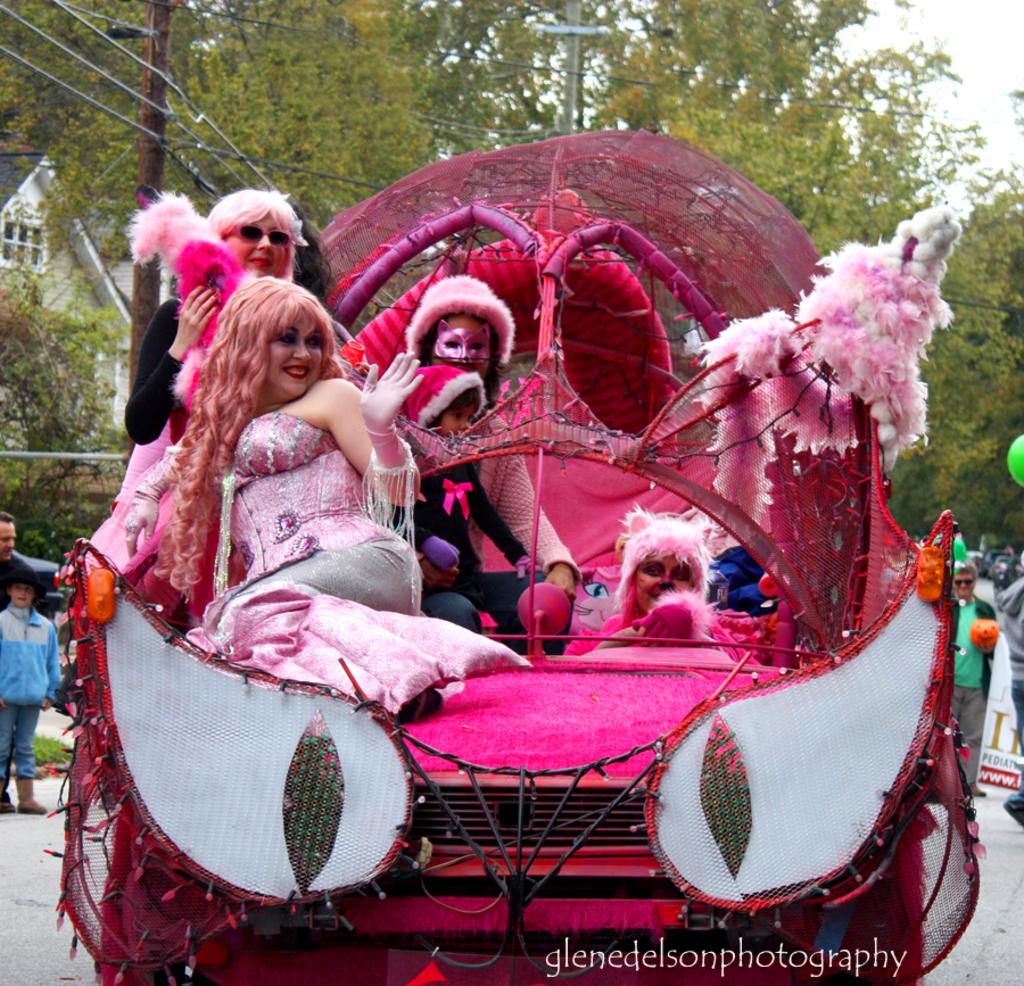Could you give a brief overview of what you see in this image? In this image, there is an outside view. In the foreground, there are some persons sitting on the car. There is a pole in the top left of the image. In the background, there are some trees. 